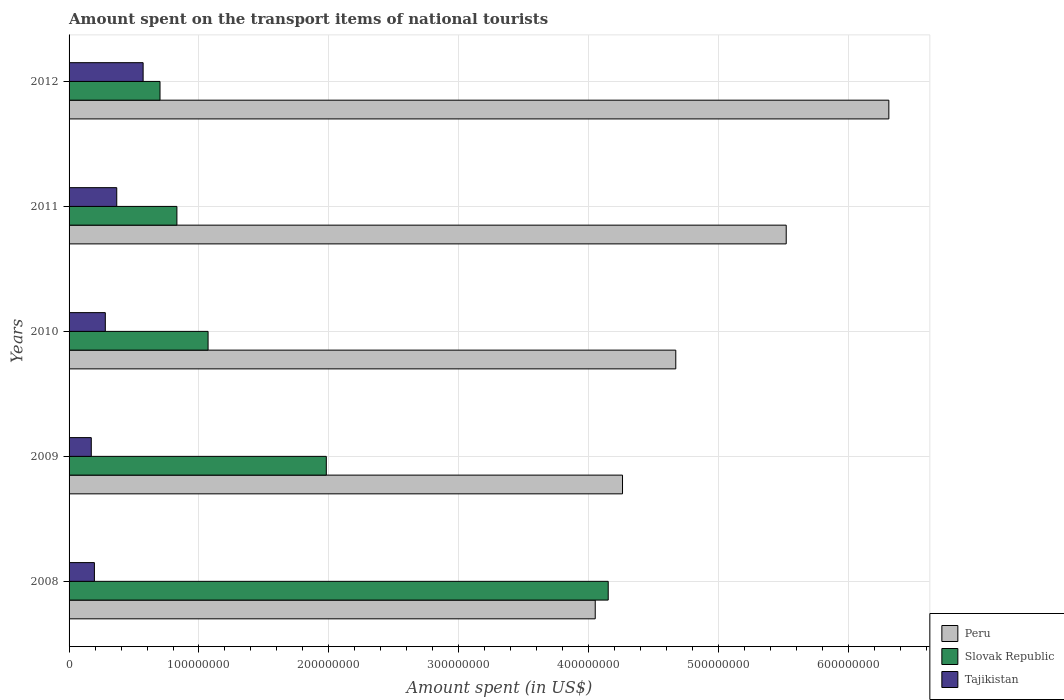How many groups of bars are there?
Offer a terse response. 5. What is the amount spent on the transport items of national tourists in Slovak Republic in 2012?
Offer a terse response. 7.00e+07. Across all years, what is the maximum amount spent on the transport items of national tourists in Slovak Republic?
Provide a short and direct response. 4.15e+08. Across all years, what is the minimum amount spent on the transport items of national tourists in Slovak Republic?
Give a very brief answer. 7.00e+07. In which year was the amount spent on the transport items of national tourists in Slovak Republic maximum?
Provide a succinct answer. 2008. In which year was the amount spent on the transport items of national tourists in Slovak Republic minimum?
Make the answer very short. 2012. What is the total amount spent on the transport items of national tourists in Tajikistan in the graph?
Your answer should be compact. 1.58e+08. What is the difference between the amount spent on the transport items of national tourists in Tajikistan in 2009 and that in 2010?
Ensure brevity in your answer.  -1.08e+07. What is the difference between the amount spent on the transport items of national tourists in Slovak Republic in 2009 and the amount spent on the transport items of national tourists in Peru in 2012?
Your answer should be compact. -4.33e+08. What is the average amount spent on the transport items of national tourists in Tajikistan per year?
Your answer should be very brief. 3.16e+07. In the year 2011, what is the difference between the amount spent on the transport items of national tourists in Peru and amount spent on the transport items of national tourists in Tajikistan?
Offer a terse response. 5.15e+08. In how many years, is the amount spent on the transport items of national tourists in Peru greater than 320000000 US$?
Provide a succinct answer. 5. What is the ratio of the amount spent on the transport items of national tourists in Tajikistan in 2008 to that in 2009?
Keep it short and to the point. 1.14. What is the difference between the highest and the second highest amount spent on the transport items of national tourists in Peru?
Ensure brevity in your answer.  7.90e+07. What is the difference between the highest and the lowest amount spent on the transport items of national tourists in Slovak Republic?
Make the answer very short. 3.45e+08. What does the 1st bar from the top in 2010 represents?
Ensure brevity in your answer.  Tajikistan. What does the 2nd bar from the bottom in 2009 represents?
Make the answer very short. Slovak Republic. How many bars are there?
Ensure brevity in your answer.  15. Are all the bars in the graph horizontal?
Ensure brevity in your answer.  Yes. What is the difference between two consecutive major ticks on the X-axis?
Offer a very short reply. 1.00e+08. Are the values on the major ticks of X-axis written in scientific E-notation?
Provide a succinct answer. No. Does the graph contain any zero values?
Provide a succinct answer. No. Where does the legend appear in the graph?
Provide a short and direct response. Bottom right. What is the title of the graph?
Provide a succinct answer. Amount spent on the transport items of national tourists. Does "World" appear as one of the legend labels in the graph?
Your answer should be very brief. No. What is the label or title of the X-axis?
Provide a succinct answer. Amount spent (in US$). What is the label or title of the Y-axis?
Offer a very short reply. Years. What is the Amount spent (in US$) in Peru in 2008?
Offer a terse response. 4.05e+08. What is the Amount spent (in US$) of Slovak Republic in 2008?
Keep it short and to the point. 4.15e+08. What is the Amount spent (in US$) of Tajikistan in 2008?
Ensure brevity in your answer.  1.95e+07. What is the Amount spent (in US$) in Peru in 2009?
Make the answer very short. 4.26e+08. What is the Amount spent (in US$) in Slovak Republic in 2009?
Your answer should be very brief. 1.98e+08. What is the Amount spent (in US$) of Tajikistan in 2009?
Keep it short and to the point. 1.71e+07. What is the Amount spent (in US$) of Peru in 2010?
Your answer should be compact. 4.67e+08. What is the Amount spent (in US$) of Slovak Republic in 2010?
Offer a very short reply. 1.07e+08. What is the Amount spent (in US$) of Tajikistan in 2010?
Ensure brevity in your answer.  2.79e+07. What is the Amount spent (in US$) of Peru in 2011?
Your answer should be compact. 5.52e+08. What is the Amount spent (in US$) in Slovak Republic in 2011?
Your answer should be very brief. 8.30e+07. What is the Amount spent (in US$) in Tajikistan in 2011?
Give a very brief answer. 3.67e+07. What is the Amount spent (in US$) of Peru in 2012?
Your answer should be compact. 6.31e+08. What is the Amount spent (in US$) of Slovak Republic in 2012?
Your answer should be very brief. 7.00e+07. What is the Amount spent (in US$) of Tajikistan in 2012?
Offer a terse response. 5.70e+07. Across all years, what is the maximum Amount spent (in US$) of Peru?
Ensure brevity in your answer.  6.31e+08. Across all years, what is the maximum Amount spent (in US$) of Slovak Republic?
Offer a very short reply. 4.15e+08. Across all years, what is the maximum Amount spent (in US$) of Tajikistan?
Provide a succinct answer. 5.70e+07. Across all years, what is the minimum Amount spent (in US$) of Peru?
Ensure brevity in your answer.  4.05e+08. Across all years, what is the minimum Amount spent (in US$) of Slovak Republic?
Your answer should be very brief. 7.00e+07. Across all years, what is the minimum Amount spent (in US$) of Tajikistan?
Your response must be concise. 1.71e+07. What is the total Amount spent (in US$) in Peru in the graph?
Ensure brevity in your answer.  2.48e+09. What is the total Amount spent (in US$) in Slovak Republic in the graph?
Provide a succinct answer. 8.73e+08. What is the total Amount spent (in US$) in Tajikistan in the graph?
Offer a terse response. 1.58e+08. What is the difference between the Amount spent (in US$) in Peru in 2008 and that in 2009?
Offer a terse response. -2.10e+07. What is the difference between the Amount spent (in US$) of Slovak Republic in 2008 and that in 2009?
Your answer should be compact. 2.17e+08. What is the difference between the Amount spent (in US$) in Tajikistan in 2008 and that in 2009?
Ensure brevity in your answer.  2.40e+06. What is the difference between the Amount spent (in US$) of Peru in 2008 and that in 2010?
Your response must be concise. -6.20e+07. What is the difference between the Amount spent (in US$) of Slovak Republic in 2008 and that in 2010?
Keep it short and to the point. 3.08e+08. What is the difference between the Amount spent (in US$) in Tajikistan in 2008 and that in 2010?
Your answer should be very brief. -8.40e+06. What is the difference between the Amount spent (in US$) of Peru in 2008 and that in 2011?
Give a very brief answer. -1.47e+08. What is the difference between the Amount spent (in US$) of Slovak Republic in 2008 and that in 2011?
Your response must be concise. 3.32e+08. What is the difference between the Amount spent (in US$) in Tajikistan in 2008 and that in 2011?
Ensure brevity in your answer.  -1.72e+07. What is the difference between the Amount spent (in US$) in Peru in 2008 and that in 2012?
Make the answer very short. -2.26e+08. What is the difference between the Amount spent (in US$) in Slovak Republic in 2008 and that in 2012?
Give a very brief answer. 3.45e+08. What is the difference between the Amount spent (in US$) in Tajikistan in 2008 and that in 2012?
Keep it short and to the point. -3.75e+07. What is the difference between the Amount spent (in US$) in Peru in 2009 and that in 2010?
Your answer should be very brief. -4.10e+07. What is the difference between the Amount spent (in US$) of Slovak Republic in 2009 and that in 2010?
Your answer should be very brief. 9.10e+07. What is the difference between the Amount spent (in US$) in Tajikistan in 2009 and that in 2010?
Offer a very short reply. -1.08e+07. What is the difference between the Amount spent (in US$) of Peru in 2009 and that in 2011?
Your answer should be very brief. -1.26e+08. What is the difference between the Amount spent (in US$) of Slovak Republic in 2009 and that in 2011?
Give a very brief answer. 1.15e+08. What is the difference between the Amount spent (in US$) in Tajikistan in 2009 and that in 2011?
Provide a succinct answer. -1.96e+07. What is the difference between the Amount spent (in US$) in Peru in 2009 and that in 2012?
Your response must be concise. -2.05e+08. What is the difference between the Amount spent (in US$) of Slovak Republic in 2009 and that in 2012?
Your response must be concise. 1.28e+08. What is the difference between the Amount spent (in US$) in Tajikistan in 2009 and that in 2012?
Offer a terse response. -3.99e+07. What is the difference between the Amount spent (in US$) in Peru in 2010 and that in 2011?
Give a very brief answer. -8.50e+07. What is the difference between the Amount spent (in US$) in Slovak Republic in 2010 and that in 2011?
Your answer should be compact. 2.40e+07. What is the difference between the Amount spent (in US$) of Tajikistan in 2010 and that in 2011?
Offer a very short reply. -8.80e+06. What is the difference between the Amount spent (in US$) in Peru in 2010 and that in 2012?
Provide a succinct answer. -1.64e+08. What is the difference between the Amount spent (in US$) in Slovak Republic in 2010 and that in 2012?
Keep it short and to the point. 3.70e+07. What is the difference between the Amount spent (in US$) in Tajikistan in 2010 and that in 2012?
Keep it short and to the point. -2.91e+07. What is the difference between the Amount spent (in US$) in Peru in 2011 and that in 2012?
Your answer should be very brief. -7.90e+07. What is the difference between the Amount spent (in US$) in Slovak Republic in 2011 and that in 2012?
Offer a terse response. 1.30e+07. What is the difference between the Amount spent (in US$) of Tajikistan in 2011 and that in 2012?
Your response must be concise. -2.03e+07. What is the difference between the Amount spent (in US$) in Peru in 2008 and the Amount spent (in US$) in Slovak Republic in 2009?
Ensure brevity in your answer.  2.07e+08. What is the difference between the Amount spent (in US$) in Peru in 2008 and the Amount spent (in US$) in Tajikistan in 2009?
Offer a very short reply. 3.88e+08. What is the difference between the Amount spent (in US$) of Slovak Republic in 2008 and the Amount spent (in US$) of Tajikistan in 2009?
Your answer should be compact. 3.98e+08. What is the difference between the Amount spent (in US$) of Peru in 2008 and the Amount spent (in US$) of Slovak Republic in 2010?
Your response must be concise. 2.98e+08. What is the difference between the Amount spent (in US$) in Peru in 2008 and the Amount spent (in US$) in Tajikistan in 2010?
Make the answer very short. 3.77e+08. What is the difference between the Amount spent (in US$) in Slovak Republic in 2008 and the Amount spent (in US$) in Tajikistan in 2010?
Keep it short and to the point. 3.87e+08. What is the difference between the Amount spent (in US$) in Peru in 2008 and the Amount spent (in US$) in Slovak Republic in 2011?
Provide a short and direct response. 3.22e+08. What is the difference between the Amount spent (in US$) in Peru in 2008 and the Amount spent (in US$) in Tajikistan in 2011?
Keep it short and to the point. 3.68e+08. What is the difference between the Amount spent (in US$) in Slovak Republic in 2008 and the Amount spent (in US$) in Tajikistan in 2011?
Your response must be concise. 3.78e+08. What is the difference between the Amount spent (in US$) of Peru in 2008 and the Amount spent (in US$) of Slovak Republic in 2012?
Make the answer very short. 3.35e+08. What is the difference between the Amount spent (in US$) of Peru in 2008 and the Amount spent (in US$) of Tajikistan in 2012?
Your response must be concise. 3.48e+08. What is the difference between the Amount spent (in US$) of Slovak Republic in 2008 and the Amount spent (in US$) of Tajikistan in 2012?
Your answer should be very brief. 3.58e+08. What is the difference between the Amount spent (in US$) of Peru in 2009 and the Amount spent (in US$) of Slovak Republic in 2010?
Provide a succinct answer. 3.19e+08. What is the difference between the Amount spent (in US$) of Peru in 2009 and the Amount spent (in US$) of Tajikistan in 2010?
Offer a very short reply. 3.98e+08. What is the difference between the Amount spent (in US$) of Slovak Republic in 2009 and the Amount spent (in US$) of Tajikistan in 2010?
Make the answer very short. 1.70e+08. What is the difference between the Amount spent (in US$) in Peru in 2009 and the Amount spent (in US$) in Slovak Republic in 2011?
Offer a terse response. 3.43e+08. What is the difference between the Amount spent (in US$) in Peru in 2009 and the Amount spent (in US$) in Tajikistan in 2011?
Your answer should be compact. 3.89e+08. What is the difference between the Amount spent (in US$) in Slovak Republic in 2009 and the Amount spent (in US$) in Tajikistan in 2011?
Offer a terse response. 1.61e+08. What is the difference between the Amount spent (in US$) in Peru in 2009 and the Amount spent (in US$) in Slovak Republic in 2012?
Provide a succinct answer. 3.56e+08. What is the difference between the Amount spent (in US$) of Peru in 2009 and the Amount spent (in US$) of Tajikistan in 2012?
Offer a terse response. 3.69e+08. What is the difference between the Amount spent (in US$) in Slovak Republic in 2009 and the Amount spent (in US$) in Tajikistan in 2012?
Your answer should be very brief. 1.41e+08. What is the difference between the Amount spent (in US$) in Peru in 2010 and the Amount spent (in US$) in Slovak Republic in 2011?
Make the answer very short. 3.84e+08. What is the difference between the Amount spent (in US$) in Peru in 2010 and the Amount spent (in US$) in Tajikistan in 2011?
Your response must be concise. 4.30e+08. What is the difference between the Amount spent (in US$) of Slovak Republic in 2010 and the Amount spent (in US$) of Tajikistan in 2011?
Provide a short and direct response. 7.03e+07. What is the difference between the Amount spent (in US$) in Peru in 2010 and the Amount spent (in US$) in Slovak Republic in 2012?
Keep it short and to the point. 3.97e+08. What is the difference between the Amount spent (in US$) of Peru in 2010 and the Amount spent (in US$) of Tajikistan in 2012?
Keep it short and to the point. 4.10e+08. What is the difference between the Amount spent (in US$) in Peru in 2011 and the Amount spent (in US$) in Slovak Republic in 2012?
Offer a terse response. 4.82e+08. What is the difference between the Amount spent (in US$) in Peru in 2011 and the Amount spent (in US$) in Tajikistan in 2012?
Your answer should be compact. 4.95e+08. What is the difference between the Amount spent (in US$) in Slovak Republic in 2011 and the Amount spent (in US$) in Tajikistan in 2012?
Keep it short and to the point. 2.60e+07. What is the average Amount spent (in US$) in Peru per year?
Provide a succinct answer. 4.96e+08. What is the average Amount spent (in US$) of Slovak Republic per year?
Offer a terse response. 1.75e+08. What is the average Amount spent (in US$) in Tajikistan per year?
Provide a succinct answer. 3.16e+07. In the year 2008, what is the difference between the Amount spent (in US$) of Peru and Amount spent (in US$) of Slovak Republic?
Your answer should be very brief. -1.00e+07. In the year 2008, what is the difference between the Amount spent (in US$) of Peru and Amount spent (in US$) of Tajikistan?
Offer a very short reply. 3.86e+08. In the year 2008, what is the difference between the Amount spent (in US$) of Slovak Republic and Amount spent (in US$) of Tajikistan?
Provide a succinct answer. 3.96e+08. In the year 2009, what is the difference between the Amount spent (in US$) in Peru and Amount spent (in US$) in Slovak Republic?
Keep it short and to the point. 2.28e+08. In the year 2009, what is the difference between the Amount spent (in US$) of Peru and Amount spent (in US$) of Tajikistan?
Your answer should be compact. 4.09e+08. In the year 2009, what is the difference between the Amount spent (in US$) in Slovak Republic and Amount spent (in US$) in Tajikistan?
Keep it short and to the point. 1.81e+08. In the year 2010, what is the difference between the Amount spent (in US$) of Peru and Amount spent (in US$) of Slovak Republic?
Provide a succinct answer. 3.60e+08. In the year 2010, what is the difference between the Amount spent (in US$) in Peru and Amount spent (in US$) in Tajikistan?
Keep it short and to the point. 4.39e+08. In the year 2010, what is the difference between the Amount spent (in US$) of Slovak Republic and Amount spent (in US$) of Tajikistan?
Give a very brief answer. 7.91e+07. In the year 2011, what is the difference between the Amount spent (in US$) of Peru and Amount spent (in US$) of Slovak Republic?
Provide a short and direct response. 4.69e+08. In the year 2011, what is the difference between the Amount spent (in US$) of Peru and Amount spent (in US$) of Tajikistan?
Your answer should be compact. 5.15e+08. In the year 2011, what is the difference between the Amount spent (in US$) in Slovak Republic and Amount spent (in US$) in Tajikistan?
Your answer should be compact. 4.63e+07. In the year 2012, what is the difference between the Amount spent (in US$) in Peru and Amount spent (in US$) in Slovak Republic?
Make the answer very short. 5.61e+08. In the year 2012, what is the difference between the Amount spent (in US$) of Peru and Amount spent (in US$) of Tajikistan?
Keep it short and to the point. 5.74e+08. In the year 2012, what is the difference between the Amount spent (in US$) of Slovak Republic and Amount spent (in US$) of Tajikistan?
Provide a succinct answer. 1.30e+07. What is the ratio of the Amount spent (in US$) in Peru in 2008 to that in 2009?
Ensure brevity in your answer.  0.95. What is the ratio of the Amount spent (in US$) in Slovak Republic in 2008 to that in 2009?
Make the answer very short. 2.1. What is the ratio of the Amount spent (in US$) of Tajikistan in 2008 to that in 2009?
Offer a very short reply. 1.14. What is the ratio of the Amount spent (in US$) in Peru in 2008 to that in 2010?
Your response must be concise. 0.87. What is the ratio of the Amount spent (in US$) of Slovak Republic in 2008 to that in 2010?
Your response must be concise. 3.88. What is the ratio of the Amount spent (in US$) of Tajikistan in 2008 to that in 2010?
Your response must be concise. 0.7. What is the ratio of the Amount spent (in US$) in Peru in 2008 to that in 2011?
Offer a terse response. 0.73. What is the ratio of the Amount spent (in US$) in Tajikistan in 2008 to that in 2011?
Offer a very short reply. 0.53. What is the ratio of the Amount spent (in US$) of Peru in 2008 to that in 2012?
Your answer should be compact. 0.64. What is the ratio of the Amount spent (in US$) in Slovak Republic in 2008 to that in 2012?
Provide a short and direct response. 5.93. What is the ratio of the Amount spent (in US$) of Tajikistan in 2008 to that in 2012?
Provide a succinct answer. 0.34. What is the ratio of the Amount spent (in US$) in Peru in 2009 to that in 2010?
Provide a short and direct response. 0.91. What is the ratio of the Amount spent (in US$) in Slovak Republic in 2009 to that in 2010?
Ensure brevity in your answer.  1.85. What is the ratio of the Amount spent (in US$) of Tajikistan in 2009 to that in 2010?
Provide a succinct answer. 0.61. What is the ratio of the Amount spent (in US$) of Peru in 2009 to that in 2011?
Your answer should be compact. 0.77. What is the ratio of the Amount spent (in US$) in Slovak Republic in 2009 to that in 2011?
Ensure brevity in your answer.  2.39. What is the ratio of the Amount spent (in US$) in Tajikistan in 2009 to that in 2011?
Provide a succinct answer. 0.47. What is the ratio of the Amount spent (in US$) in Peru in 2009 to that in 2012?
Provide a short and direct response. 0.68. What is the ratio of the Amount spent (in US$) in Slovak Republic in 2009 to that in 2012?
Keep it short and to the point. 2.83. What is the ratio of the Amount spent (in US$) in Tajikistan in 2009 to that in 2012?
Your answer should be very brief. 0.3. What is the ratio of the Amount spent (in US$) of Peru in 2010 to that in 2011?
Keep it short and to the point. 0.85. What is the ratio of the Amount spent (in US$) of Slovak Republic in 2010 to that in 2011?
Ensure brevity in your answer.  1.29. What is the ratio of the Amount spent (in US$) in Tajikistan in 2010 to that in 2011?
Give a very brief answer. 0.76. What is the ratio of the Amount spent (in US$) in Peru in 2010 to that in 2012?
Make the answer very short. 0.74. What is the ratio of the Amount spent (in US$) of Slovak Republic in 2010 to that in 2012?
Give a very brief answer. 1.53. What is the ratio of the Amount spent (in US$) in Tajikistan in 2010 to that in 2012?
Provide a succinct answer. 0.49. What is the ratio of the Amount spent (in US$) in Peru in 2011 to that in 2012?
Make the answer very short. 0.87. What is the ratio of the Amount spent (in US$) of Slovak Republic in 2011 to that in 2012?
Give a very brief answer. 1.19. What is the ratio of the Amount spent (in US$) in Tajikistan in 2011 to that in 2012?
Offer a very short reply. 0.64. What is the difference between the highest and the second highest Amount spent (in US$) in Peru?
Offer a terse response. 7.90e+07. What is the difference between the highest and the second highest Amount spent (in US$) in Slovak Republic?
Give a very brief answer. 2.17e+08. What is the difference between the highest and the second highest Amount spent (in US$) of Tajikistan?
Make the answer very short. 2.03e+07. What is the difference between the highest and the lowest Amount spent (in US$) in Peru?
Make the answer very short. 2.26e+08. What is the difference between the highest and the lowest Amount spent (in US$) in Slovak Republic?
Offer a very short reply. 3.45e+08. What is the difference between the highest and the lowest Amount spent (in US$) in Tajikistan?
Give a very brief answer. 3.99e+07. 